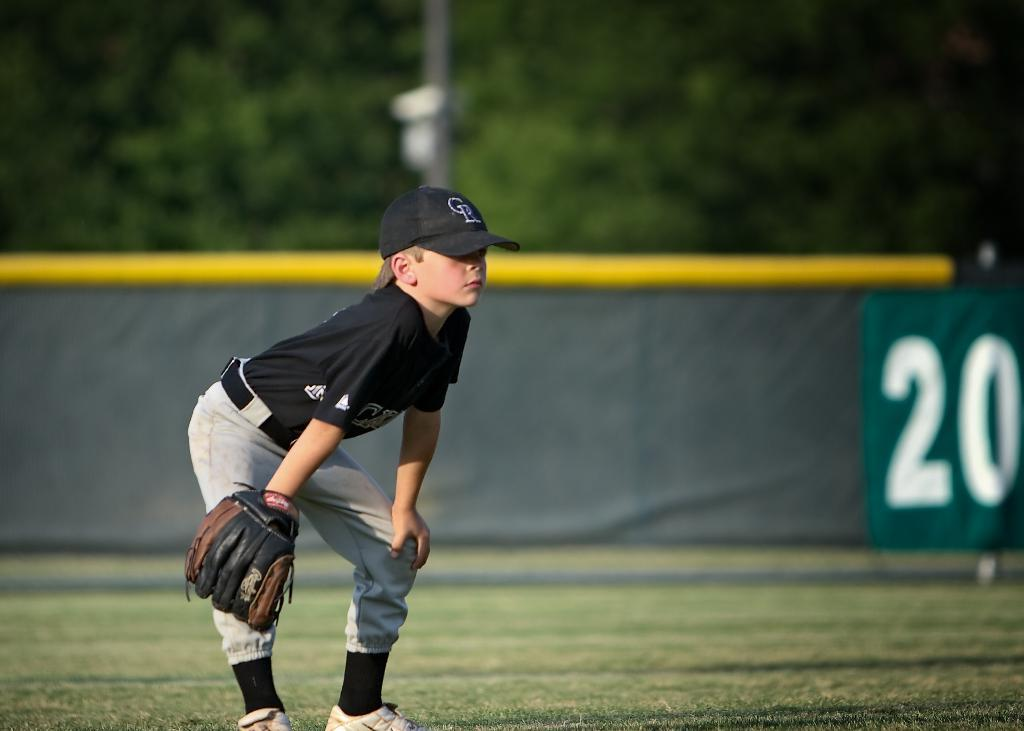<image>
Summarize the visual content of the image. A young boy in a baseball uniform and a cap with the letters CR on it is bent over with his hands on his knees. 